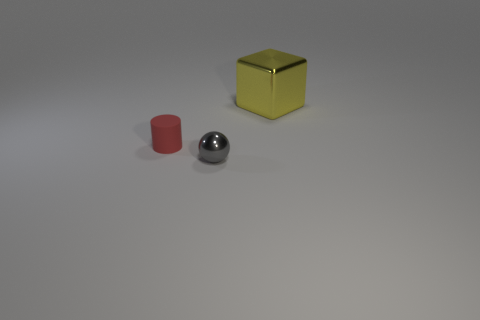Add 1 tiny gray balls. How many objects exist? 4 Subtract all spheres. How many objects are left? 2 Add 1 small gray blocks. How many small gray blocks exist? 1 Subtract 0 red cubes. How many objects are left? 3 Subtract all purple matte cubes. Subtract all gray metallic things. How many objects are left? 2 Add 1 small red matte cylinders. How many small red matte cylinders are left? 2 